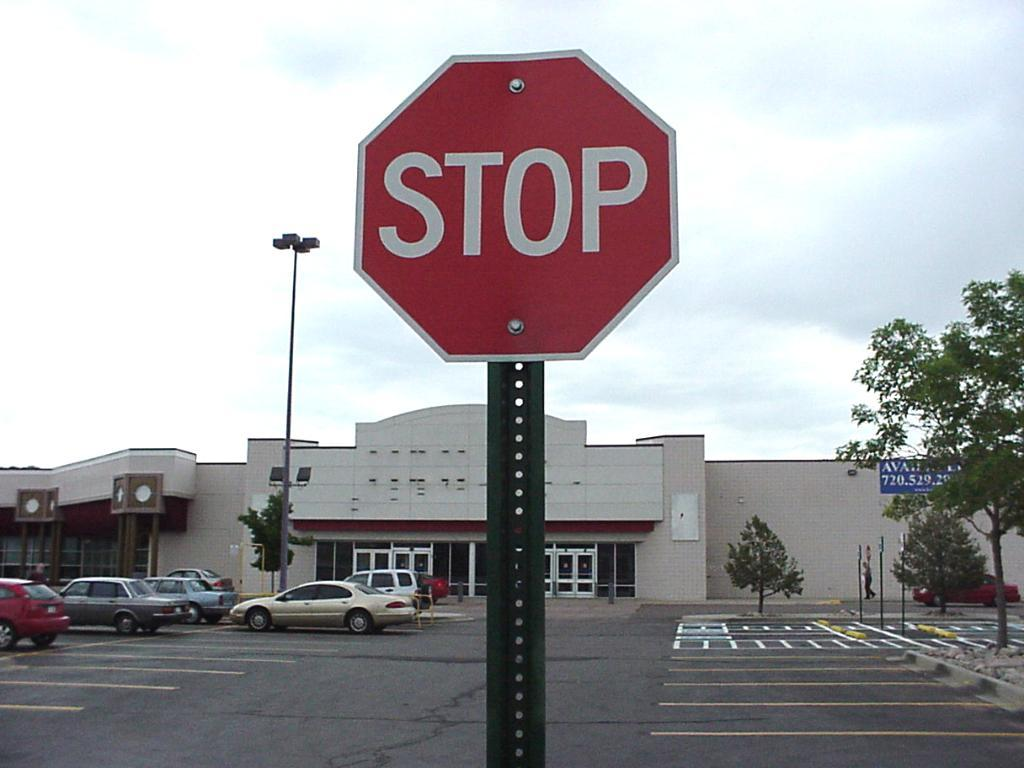<image>
Write a terse but informative summary of the picture. a stop sign that is outside in the day 